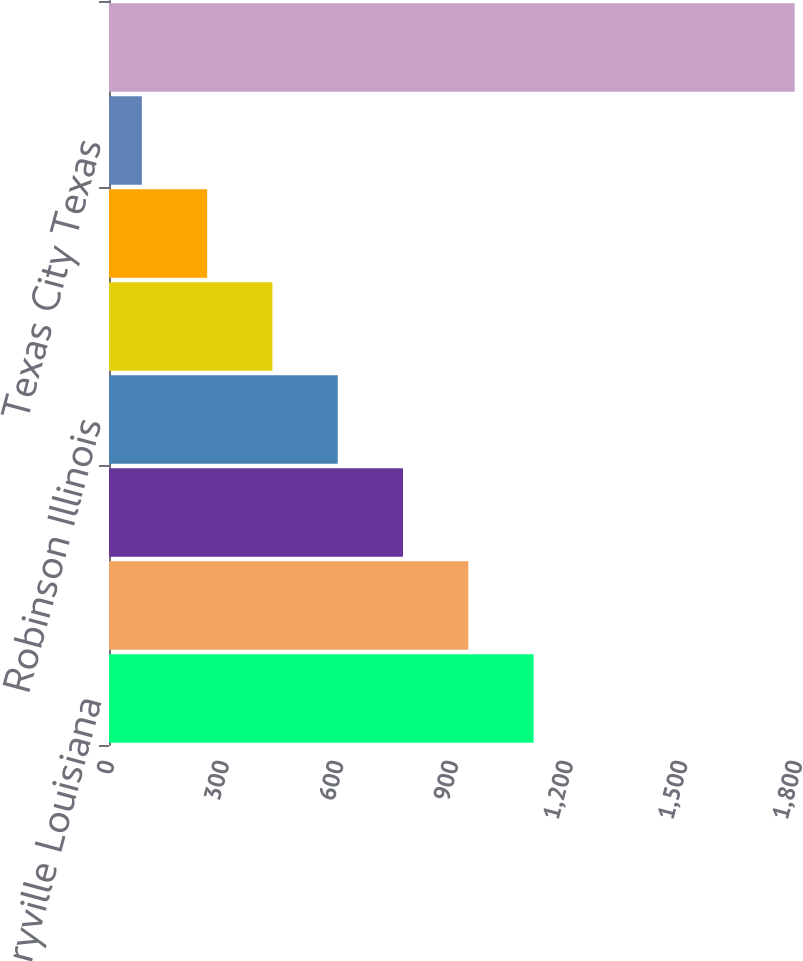<chart> <loc_0><loc_0><loc_500><loc_500><bar_chart><fcel>Garyville Louisiana<fcel>Galveston Bay Texas City Texas<fcel>Catlettsburg Kentucky<fcel>Robinson Illinois<fcel>Detroit Michigan<fcel>Canton Ohio<fcel>Texas City Texas<fcel>Total<nl><fcel>1110.8<fcel>940<fcel>769.2<fcel>598.4<fcel>427.6<fcel>256.8<fcel>86<fcel>1794<nl></chart> 